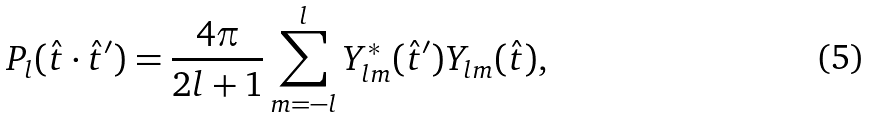Convert formula to latex. <formula><loc_0><loc_0><loc_500><loc_500>P _ { l } ( { \hat { t } } \cdot { \hat { t } } ^ { \prime } ) = \frac { 4 \pi } { 2 l + 1 } \sum _ { m = - l } ^ { l } Y _ { l m } ^ { * } ( \hat { t } ^ { \prime } ) Y _ { l m } ( \hat { t } ) ,</formula> 